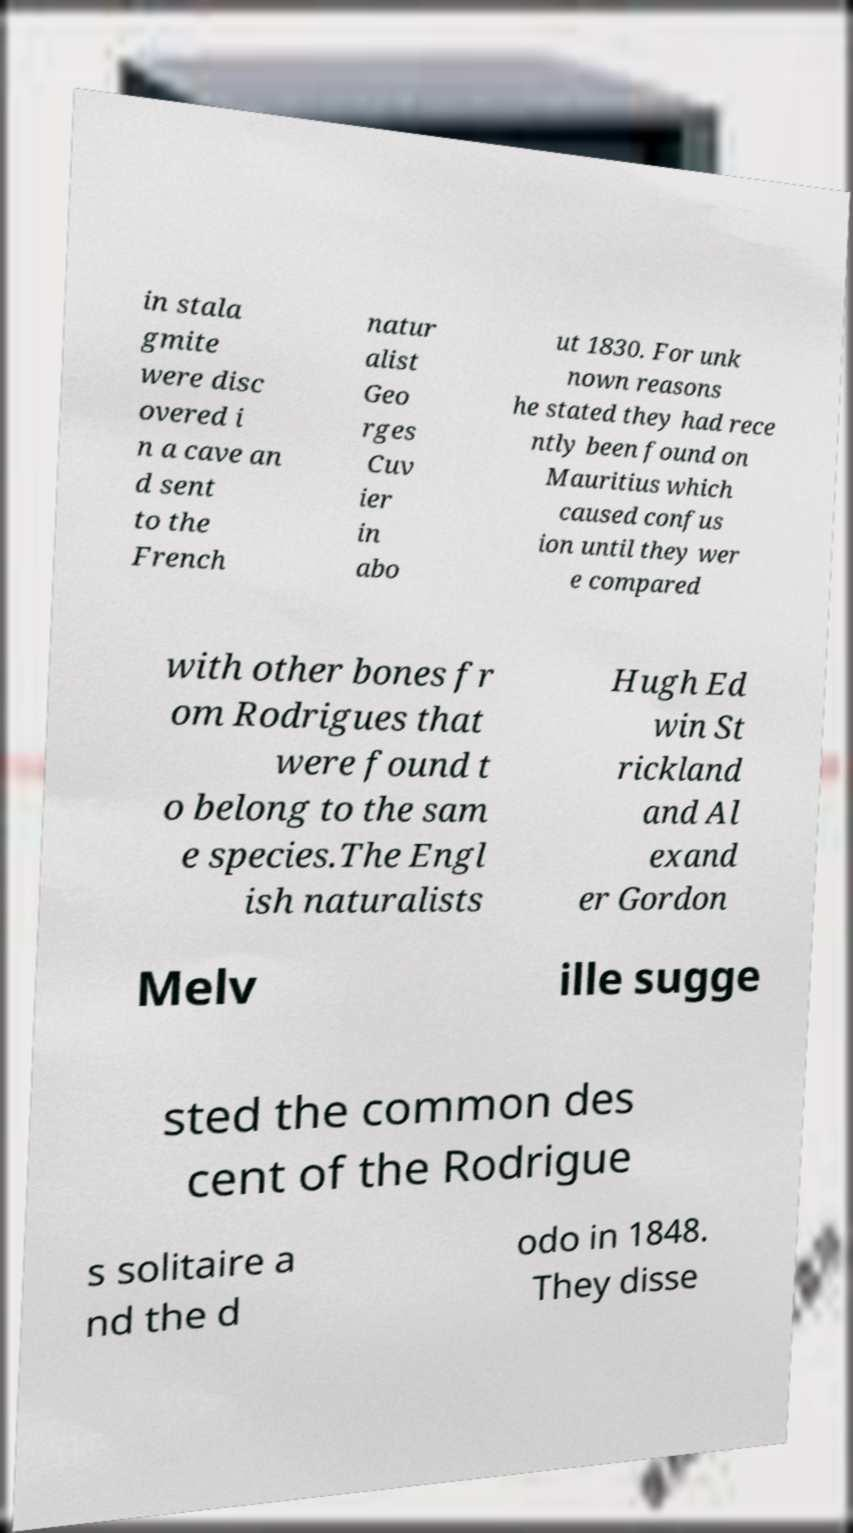Could you extract and type out the text from this image? in stala gmite were disc overed i n a cave an d sent to the French natur alist Geo rges Cuv ier in abo ut 1830. For unk nown reasons he stated they had rece ntly been found on Mauritius which caused confus ion until they wer e compared with other bones fr om Rodrigues that were found t o belong to the sam e species.The Engl ish naturalists Hugh Ed win St rickland and Al exand er Gordon Melv ille sugge sted the common des cent of the Rodrigue s solitaire a nd the d odo in 1848. They disse 